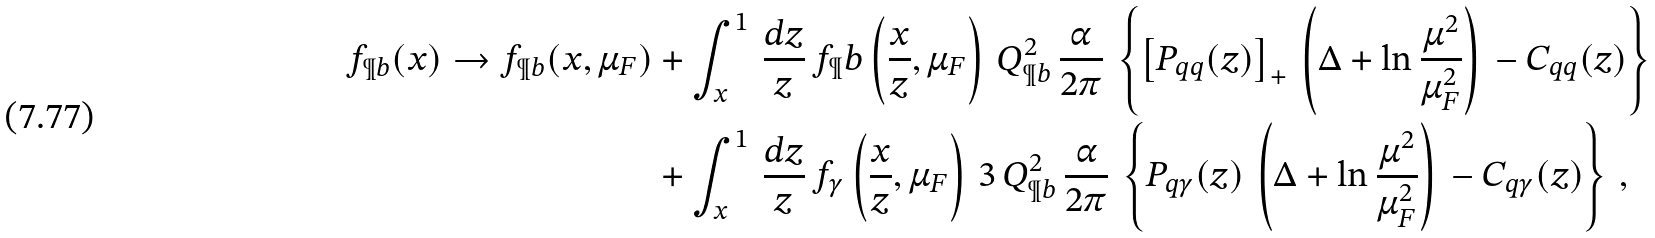<formula> <loc_0><loc_0><loc_500><loc_500>f _ { \P b } ( x ) \to f _ { \P b } ( x , \mu _ { F } ) & + \int _ { x } ^ { 1 } \, \frac { d z } { z } \, f _ { \P } b \left ( \frac { x } { z } , \mu _ { F } \right ) \, Q _ { \P b } ^ { 2 } \, \frac { \alpha } { 2 \pi } \, \left \{ \left [ P _ { q q } ( z ) \right ] _ { + } \, \left ( \Delta + \ln \frac { \mu ^ { 2 } } { \mu _ { F } ^ { 2 } } \right ) \, - C _ { q q } ( z ) \right \} \, \\ & + \int _ { x } ^ { 1 } \, \frac { d z } { z } \, f _ { \gamma } \left ( \frac { x } { z } , \mu _ { F } \right ) \, 3 \, Q _ { \P b } ^ { 2 } \, \frac { \alpha } { 2 \pi } \, \left \{ P _ { q \gamma } ( z ) \, \left ( \Delta + \ln \frac { \mu ^ { 2 } } { \mu _ { F } ^ { 2 } } \right ) \, - C _ { q \gamma } ( z ) \right \} \, ,</formula> 